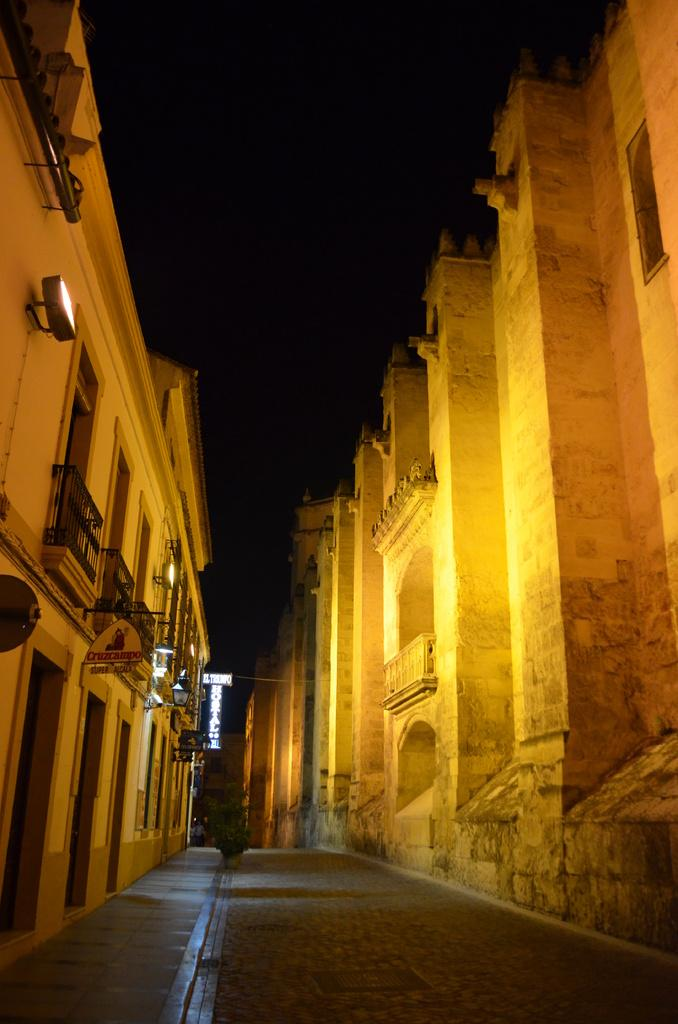What type of structure is located on the left side of the image? There is a huge building on the left side of the image. What can be seen on the right side of the image? There is a fort on the right side of the image. What is the surface between the building and the fort in the image? There is a pavement between the building and the fort in the image. What type of marble is used to decorate the zoo in the image? There is no zoo present in the image, and therefore no marble can be observed. What type of dinner is being served in the image? There is no dinner or any food being served in the image. 